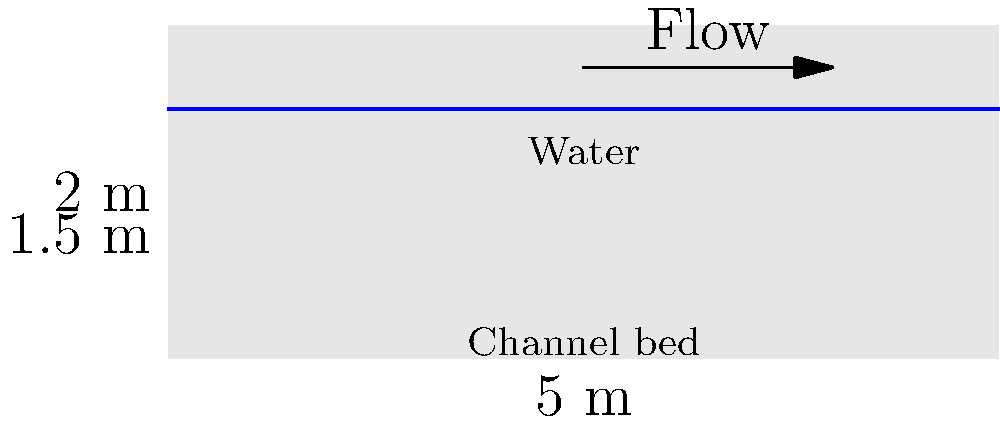In a rectangular open channel with a width of 5 meters and a total depth of 2 meters, water is flowing at a depth of 1.5 meters. If the average velocity of the water is 2 m/s, what is the flow rate in the channel? To solve this problem, we'll use the continuity equation for open channel flow:

$$Q = A \times v$$

Where:
$Q$ = Flow rate (m³/s)
$A$ = Cross-sectional area of flow (m²)
$v$ = Average velocity (m/s)

Step 1: Calculate the cross-sectional area of flow (A)
The cross-sectional area is rectangular, so:
$$A = \text{width} \times \text{water depth}$$
$$A = 5 \text{ m} \times 1.5 \text{ m} = 7.5 \text{ m}^2$$

Step 2: Use the given average velocity
$v = 2 \text{ m/s}$

Step 3: Apply the continuity equation
$$Q = A \times v$$
$$Q = 7.5 \text{ m}^2 \times 2 \text{ m/s}$$
$$Q = 15 \text{ m}^3/\text{s}$$

Therefore, the flow rate in the channel is 15 cubic meters per second.
Answer: 15 m³/s 